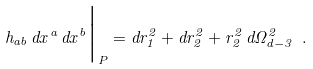<formula> <loc_0><loc_0><loc_500><loc_500>h _ { a b } \, d x ^ { a } \, d x ^ { b } \Big | _ { P } = d r _ { 1 } ^ { 2 } + d r _ { 2 } ^ { 2 } + r _ { 2 } ^ { 2 } \, d \Omega _ { d - 3 } ^ { 2 } \ .</formula> 